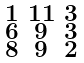Convert formula to latex. <formula><loc_0><loc_0><loc_500><loc_500>\begin{smallmatrix} 1 & 1 1 & 3 \\ 6 & 9 & 3 \\ 8 & 9 & 2 \end{smallmatrix}</formula> 